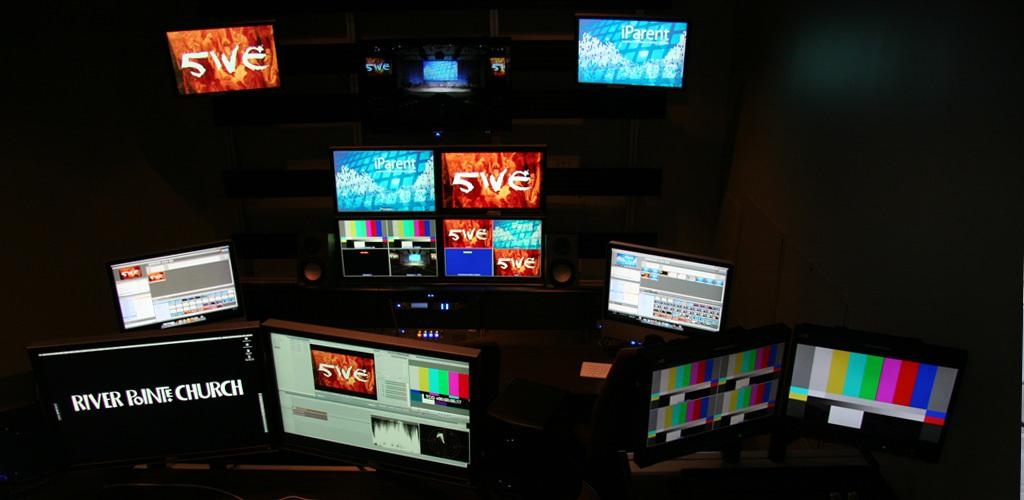<image>
Render a clear and concise summary of the photo. Several monitors, including one displaying the name River Point Church, are powered on. 